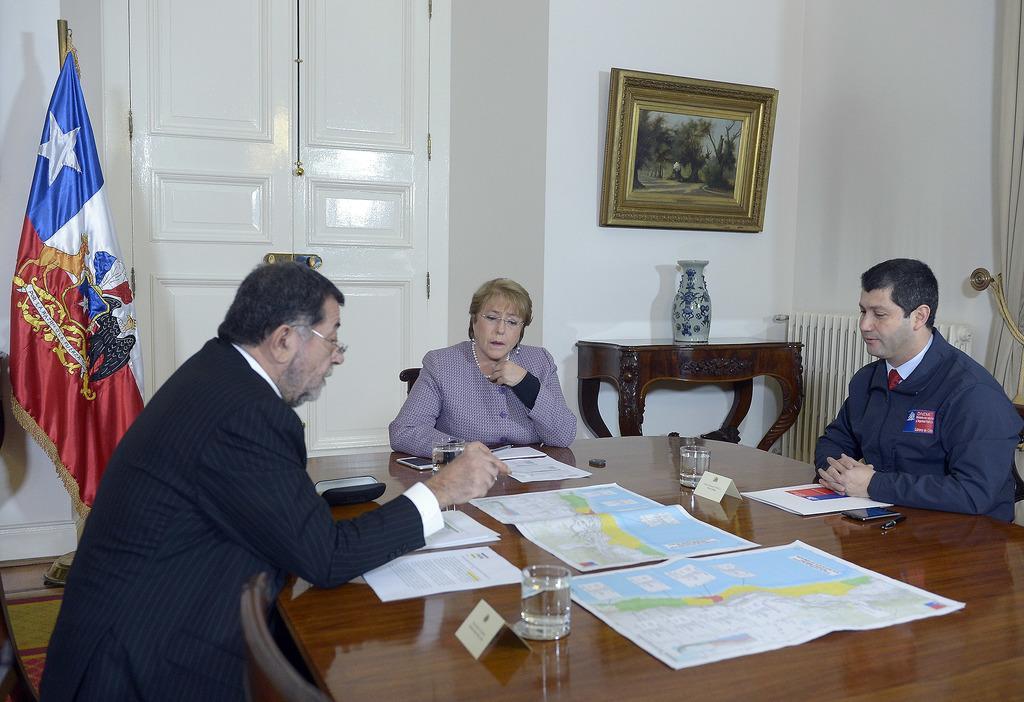Please provide a concise description of this image. in the picture we can see two men and one woman sitting on the chair listening to the person speaking, we can see different items on the table, we can also see a frame on the wall,here we can also see a flag near to the person,we can also see a flower vase on the table. 